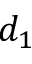<formula> <loc_0><loc_0><loc_500><loc_500>d _ { 1 }</formula> 